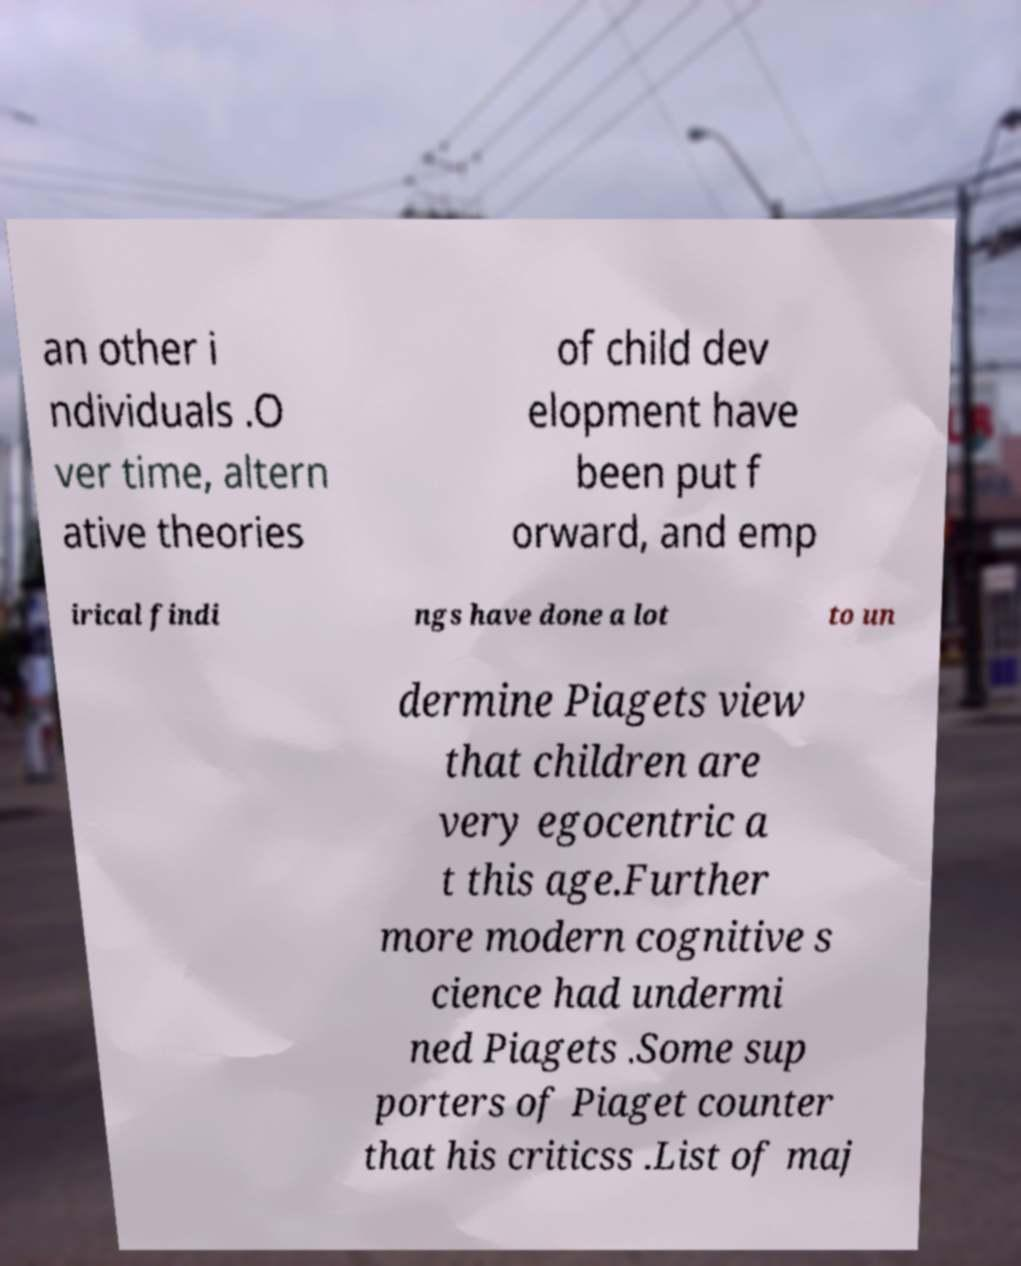For documentation purposes, I need the text within this image transcribed. Could you provide that? an other i ndividuals .O ver time, altern ative theories of child dev elopment have been put f orward, and emp irical findi ngs have done a lot to un dermine Piagets view that children are very egocentric a t this age.Further more modern cognitive s cience had undermi ned Piagets .Some sup porters of Piaget counter that his criticss .List of maj 